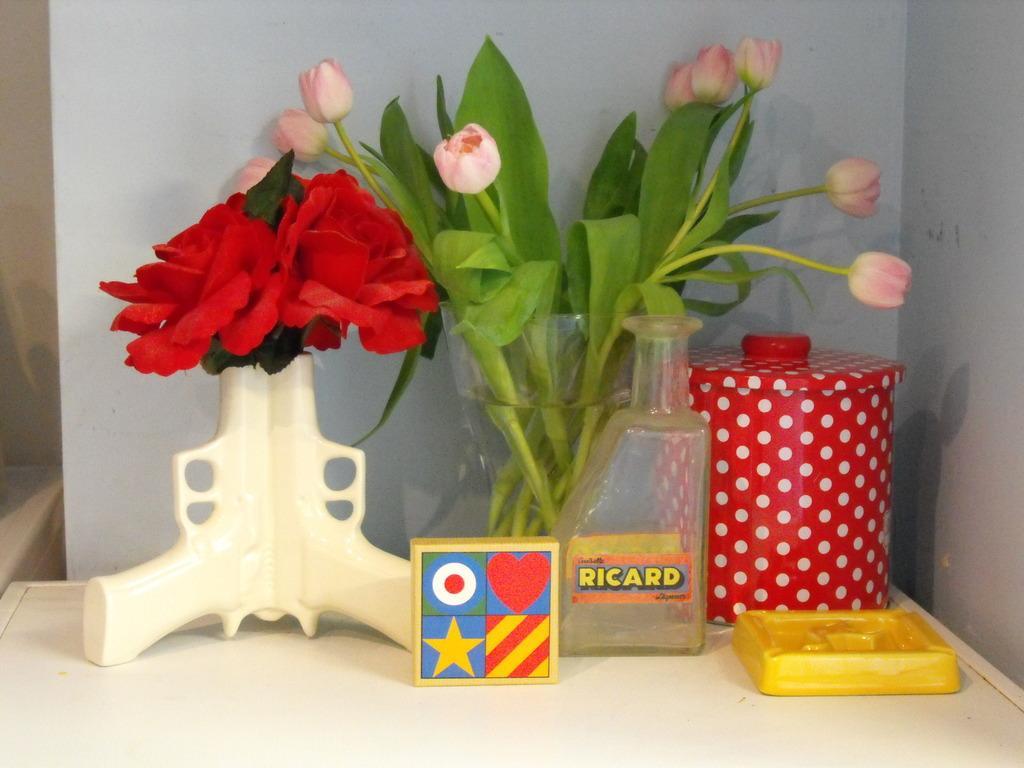Please provide a concise description of this image. In this image, we can see flowers vases, a bottle, a jar, a box and a board are on the table. In the background, there is a wall. 